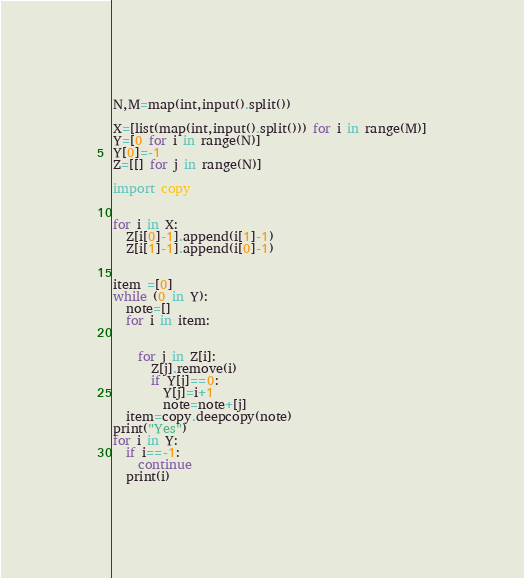Convert code to text. <code><loc_0><loc_0><loc_500><loc_500><_Python_>N,M=map(int,input().split())

X=[list(map(int,input().split())) for i in range(M)]
Y=[0 for i in range(N)]
Y[0]=-1
Z=[[] for j in range(N)]

import copy


for i in X:
  Z[i[0]-1].append(i[1]-1)
  Z[i[1]-1].append(i[0]-1)

  
item =[0]
while (0 in Y):
  note=[]
  for i in item:
    
    
    for j in Z[i]:
      Z[j].remove(i)
      if Y[j]==0:
        Y[j]=i+1
        note=note+[j]
  item=copy.deepcopy(note)
print("Yes")
for i in Y:
  if i==-1:
    continue
  print(i)</code> 